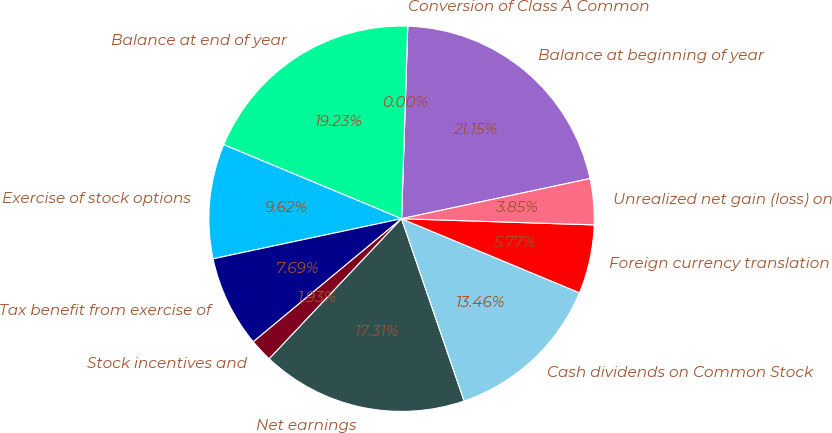<chart> <loc_0><loc_0><loc_500><loc_500><pie_chart><fcel>Balance at beginning of year<fcel>Conversion of Class A Common<fcel>Balance at end of year<fcel>Exercise of stock options<fcel>Tax benefit from exercise of<fcel>Stock incentives and<fcel>Net earnings<fcel>Cash dividends on Common Stock<fcel>Foreign currency translation<fcel>Unrealized net gain (loss) on<nl><fcel>21.15%<fcel>0.0%<fcel>19.23%<fcel>9.62%<fcel>7.69%<fcel>1.93%<fcel>17.31%<fcel>13.46%<fcel>5.77%<fcel>3.85%<nl></chart> 